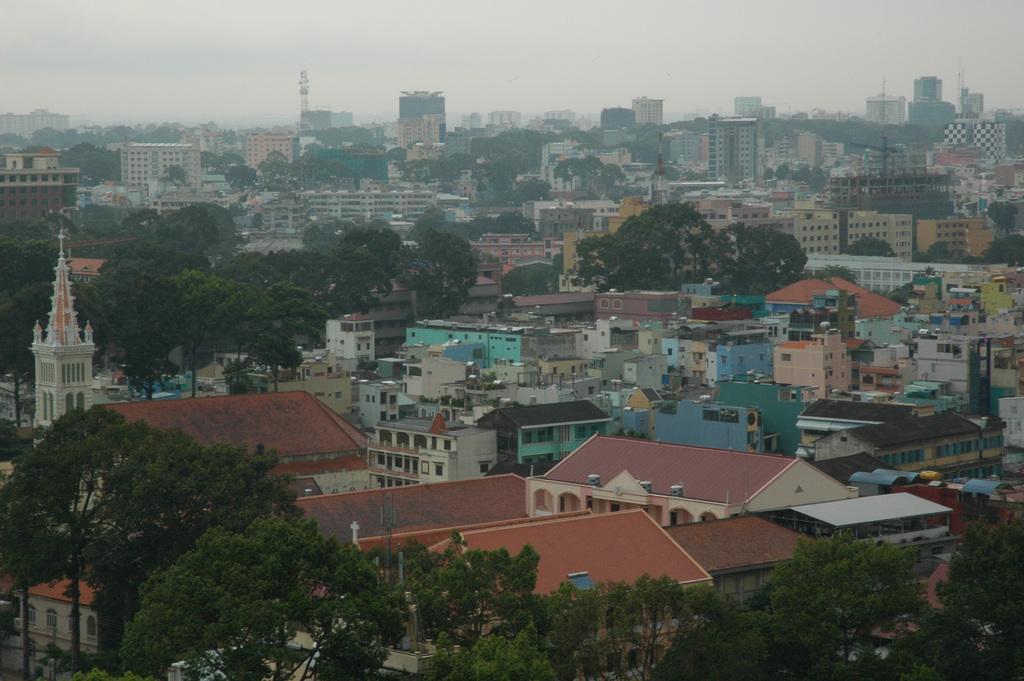In one or two sentences, can you explain what this image depicts? In this image we can see a group of buildings, a tower, some houses with roof and windows, a group of trees and the sky which looks cloudy. 